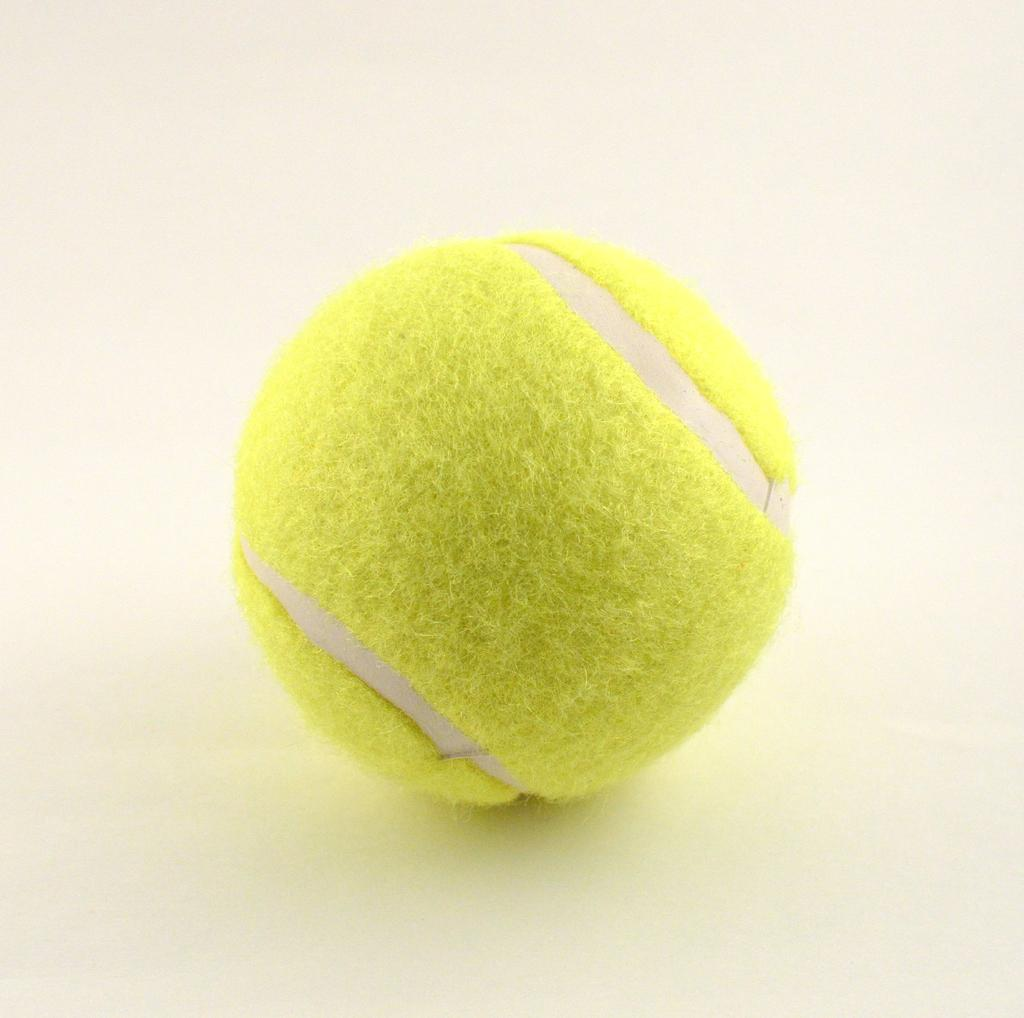What type of ball is in the image? There is a green tennis ball in the image. What color is the table on which the tennis ball is placed? The tennis ball is placed on a white table. What advice does the uncle give to the father about the tennis ball in the image? There is no father or uncle present in the image, and therefore no advice-giving can be observed. 